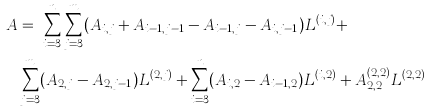Convert formula to latex. <formula><loc_0><loc_0><loc_500><loc_500>A & = \ \sum _ { i = 3 } ^ { n } \sum _ { j = 3 } ^ { m } ( A _ { i , j } + A _ { i - 1 , j - 1 } - A _ { i - 1 , j } - A _ { i , j - 1 } ) L ^ { ( i , j ) } + \\ & \sum _ { j = 3 } ^ { m } ( A _ { 2 , j } - A _ { 2 , j - 1 } ) L ^ { ( 2 , j ) } + \sum _ { i = 3 } ^ { n } ( A _ { i , 2 } - A _ { i - 1 , 2 } ) L ^ { ( i , 2 ) } + A _ { 2 , 2 } ^ { ( 2 , 2 ) } L ^ { ( 2 , 2 ) }</formula> 